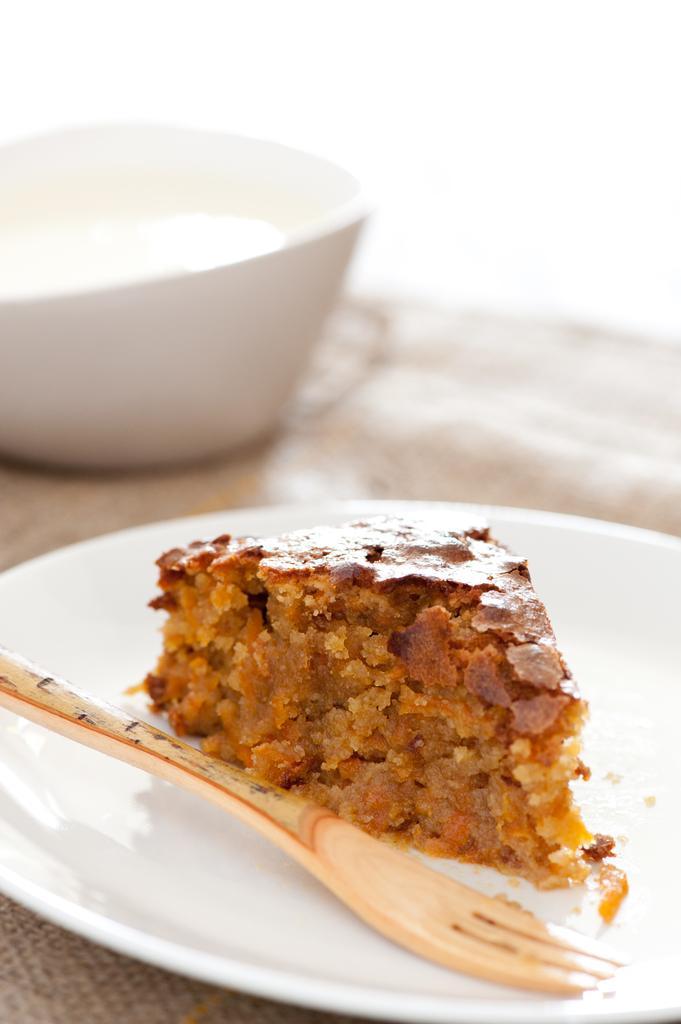Please provide a concise description of this image. There is a food item and a fork kept in a white color plate as we can see at the bottom of this image. There is a cup kept on the surface is at the top of this image. 